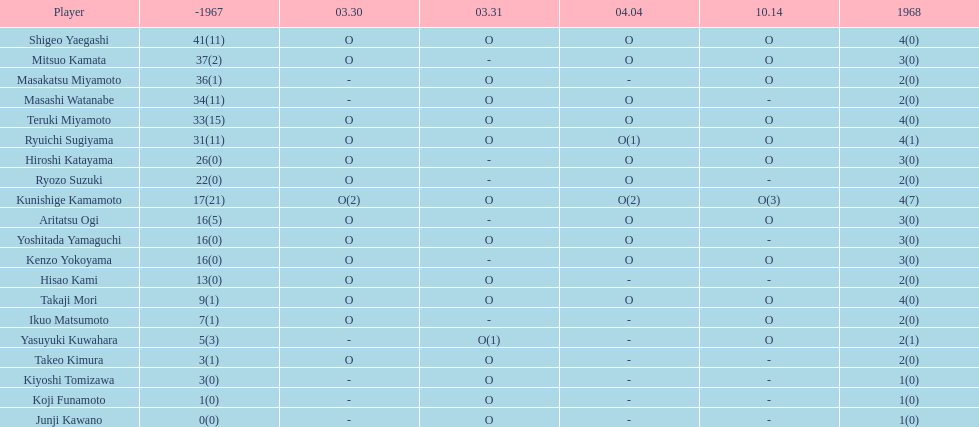How many more total appearances did shigeo yaegashi have than mitsuo kamata? 5. 